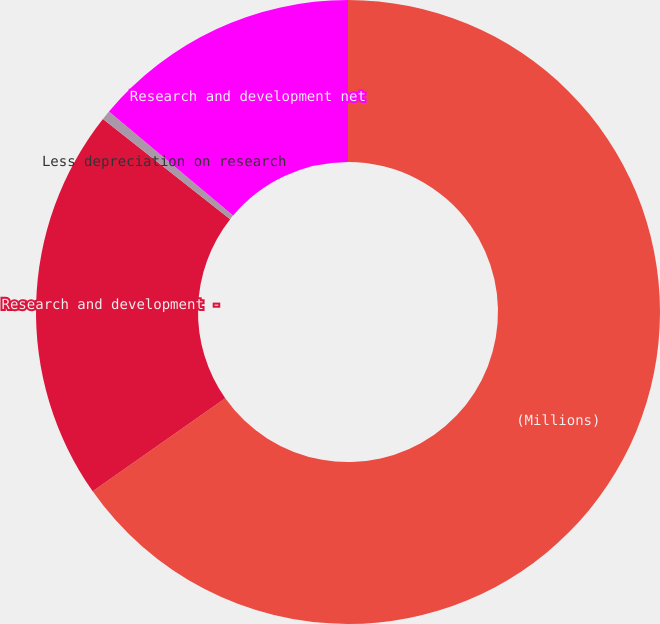<chart> <loc_0><loc_0><loc_500><loc_500><pie_chart><fcel>(Millions)<fcel>Research and development -<fcel>Less depreciation on research<fcel>Research and development net<nl><fcel>65.26%<fcel>20.37%<fcel>0.49%<fcel>13.89%<nl></chart> 